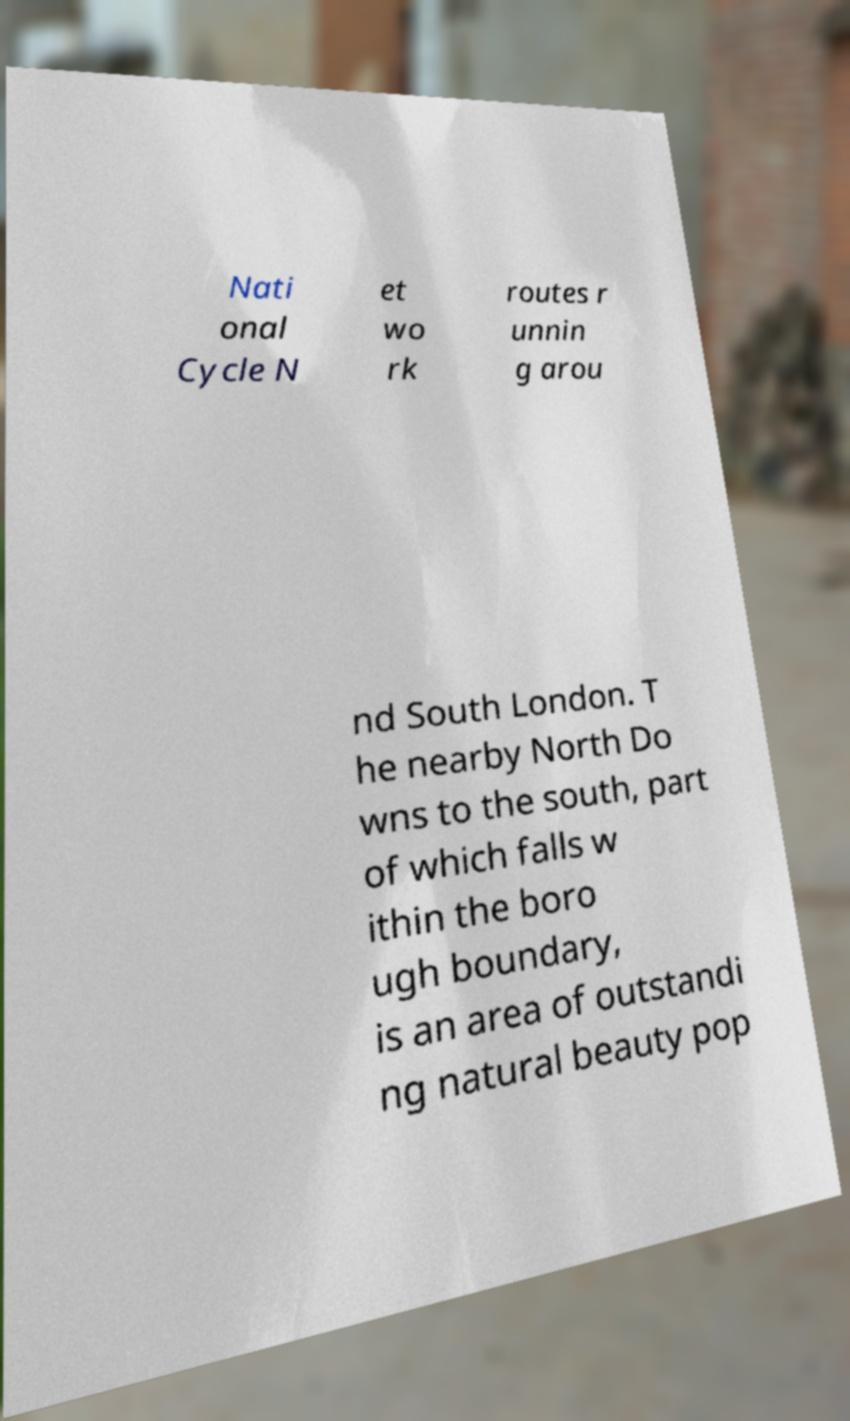Can you read and provide the text displayed in the image?This photo seems to have some interesting text. Can you extract and type it out for me? Nati onal Cycle N et wo rk routes r unnin g arou nd South London. T he nearby North Do wns to the south, part of which falls w ithin the boro ugh boundary, is an area of outstandi ng natural beauty pop 